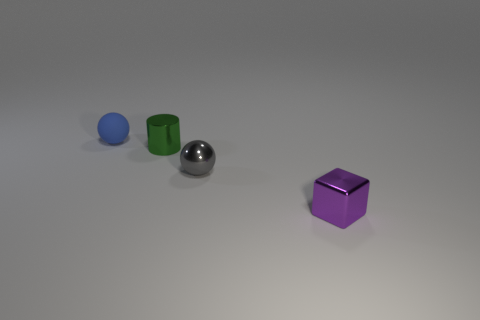Are there more objects than gray matte spheres?
Your response must be concise. Yes. There is a blue rubber object; is it the same size as the object in front of the gray thing?
Your answer should be compact. Yes. What color is the small shiny thing left of the gray metallic object?
Your answer should be very brief. Green. How many blue things are either small rubber balls or tiny metal blocks?
Offer a terse response. 1. The small cube is what color?
Provide a short and direct response. Purple. Is there any other thing that is the same material as the blue thing?
Offer a very short reply. No. Are there fewer small shiny objects on the right side of the green shiny object than tiny things to the right of the matte ball?
Ensure brevity in your answer.  Yes. What is the shape of the small metal object that is in front of the tiny green cylinder and on the left side of the block?
Provide a succinct answer. Sphere. How many tiny metallic things are the same shape as the matte thing?
Give a very brief answer. 1. What is the size of the gray object that is made of the same material as the purple thing?
Provide a short and direct response. Small. 